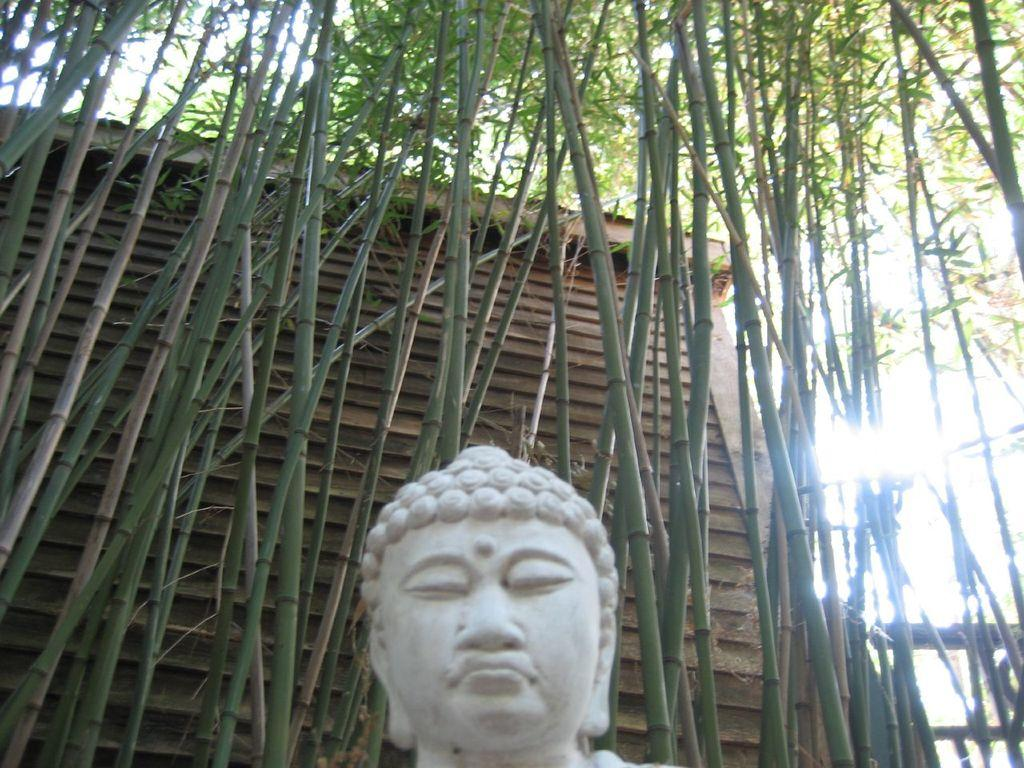What is the main subject of the image? There is a statue in the image. Where is the statue located in the image? The statue is located at the bottom of the image. What type of vegetation can be seen in the background of the image? There are bamboo trees in the background of the image. What type of fish can be seen swimming near the statue in the image? There are no fish present in the image; it features a statue and bamboo trees. How much milk is being poured onto the statue in the image? There is no milk present in the image; it features a statue and bamboo trees. 